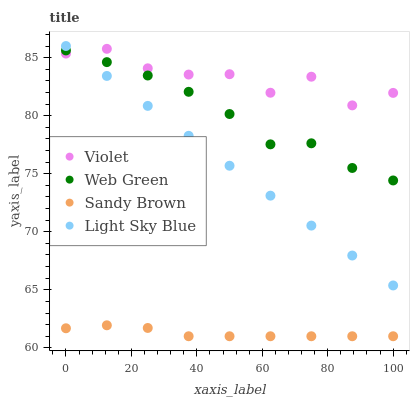Does Sandy Brown have the minimum area under the curve?
Answer yes or no. Yes. Does Violet have the maximum area under the curve?
Answer yes or no. Yes. Does Web Green have the minimum area under the curve?
Answer yes or no. No. Does Web Green have the maximum area under the curve?
Answer yes or no. No. Is Light Sky Blue the smoothest?
Answer yes or no. Yes. Is Violet the roughest?
Answer yes or no. Yes. Is Sandy Brown the smoothest?
Answer yes or no. No. Is Sandy Brown the roughest?
Answer yes or no. No. Does Sandy Brown have the lowest value?
Answer yes or no. Yes. Does Web Green have the lowest value?
Answer yes or no. No. Does Light Sky Blue have the highest value?
Answer yes or no. Yes. Does Web Green have the highest value?
Answer yes or no. No. Is Sandy Brown less than Violet?
Answer yes or no. Yes. Is Web Green greater than Sandy Brown?
Answer yes or no. Yes. Does Web Green intersect Violet?
Answer yes or no. Yes. Is Web Green less than Violet?
Answer yes or no. No. Is Web Green greater than Violet?
Answer yes or no. No. Does Sandy Brown intersect Violet?
Answer yes or no. No. 